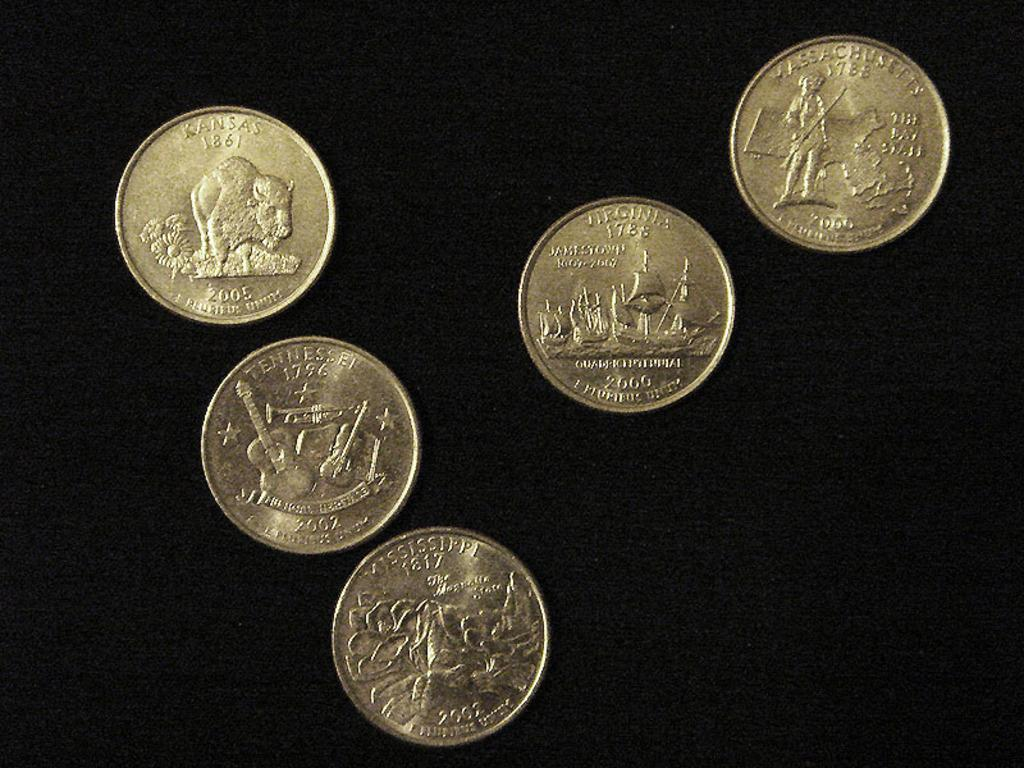<image>
Offer a succinct explanation of the picture presented. Five coins from the 18th and 19th centuries. 